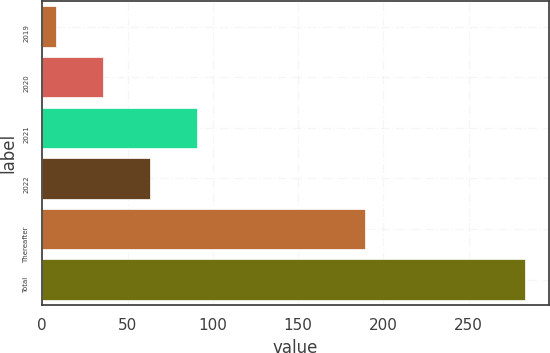<chart> <loc_0><loc_0><loc_500><loc_500><bar_chart><fcel>2019<fcel>2020<fcel>2021<fcel>2022<fcel>Thereafter<fcel>Total<nl><fcel>8<fcel>35.5<fcel>90.5<fcel>63<fcel>189<fcel>283<nl></chart> 